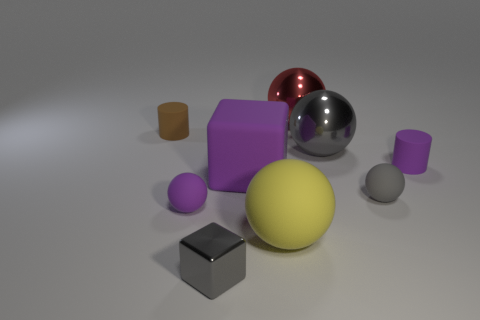What is the material of the gray sphere left of the sphere on the right side of the gray shiny object that is on the right side of the tiny gray metallic block?
Your response must be concise. Metal. What number of other things are there of the same shape as the big gray thing?
Offer a very short reply. 4. There is a metallic object that is behind the big gray shiny ball; what color is it?
Your answer should be compact. Red. There is a tiny sphere that is right of the metal object that is in front of the purple rubber ball; how many red balls are to the left of it?
Your response must be concise. 1. How many red objects are behind the purple thing that is on the right side of the tiny gray rubber sphere?
Keep it short and to the point. 1. There is a yellow matte sphere; how many small shiny objects are on the right side of it?
Your response must be concise. 0. How many other objects are there of the same size as the red sphere?
Offer a very short reply. 3. What is the size of the red metal thing that is the same shape as the small gray rubber object?
Offer a terse response. Large. There is a yellow object that is right of the brown matte thing; what is its shape?
Your answer should be very brief. Sphere. What color is the tiny matte cylinder that is left of the tiny rubber cylinder that is in front of the brown thing?
Give a very brief answer. Brown. 